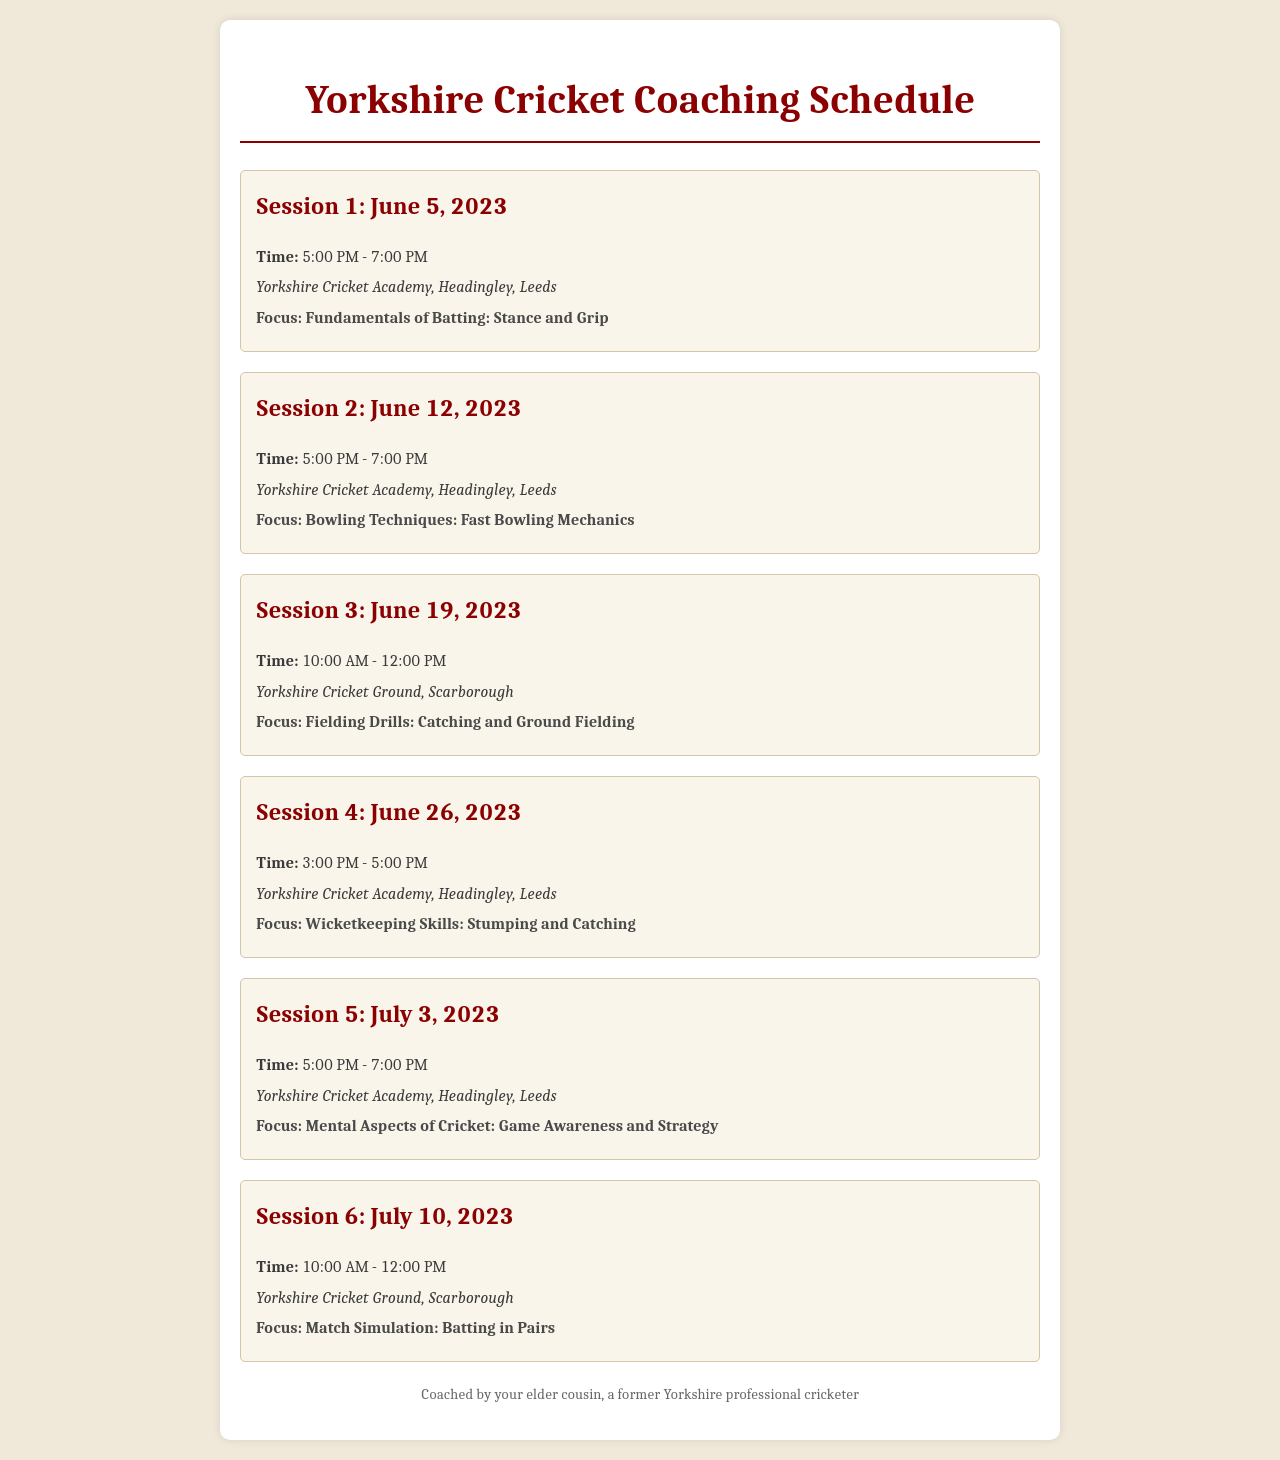What is the first coaching session date? The first coaching session is scheduled for June 5, 2023.
Answer: June 5, 2023 Where is the second session held? The second session is held at the Yorkshire Cricket Academy, Headingley, Leeds.
Answer: Yorkshire Cricket Academy, Headingley, Leeds What time does the third session start? The third session starts at 10:00 AM.
Answer: 10:00 AM What is the focus area of the fifth session? The focus area of the fifth session is the mental aspects of cricket, specifically game awareness and strategy.
Answer: Mental Aspects of Cricket: Game Awareness and Strategy How many sessions are scheduled in total? There are six coaching sessions scheduled in total.
Answer: Six What is the location for the fourth session? The location for the fourth session is Yorkshire Cricket Academy, Headingley, Leeds.
Answer: Yorkshire Cricket Academy, Headingley, Leeds What is the last session's focus area? The last session's focus area is match simulation, specifically batting in pairs.
Answer: Match Simulation: Batting in Pairs When does the last session take place? The last session takes place on July 10, 2023.
Answer: July 10, 2023 